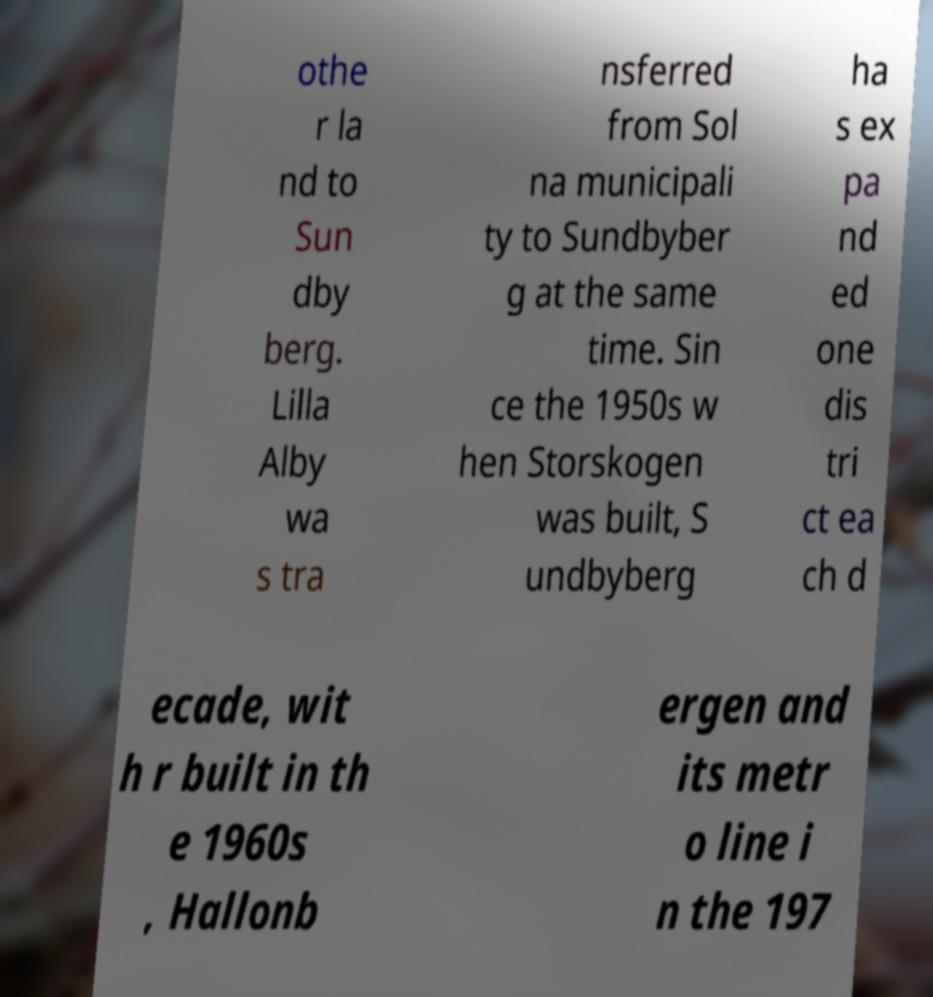There's text embedded in this image that I need extracted. Can you transcribe it verbatim? othe r la nd to Sun dby berg. Lilla Alby wa s tra nsferred from Sol na municipali ty to Sundbyber g at the same time. Sin ce the 1950s w hen Storskogen was built, S undbyberg ha s ex pa nd ed one dis tri ct ea ch d ecade, wit h r built in th e 1960s , Hallonb ergen and its metr o line i n the 197 